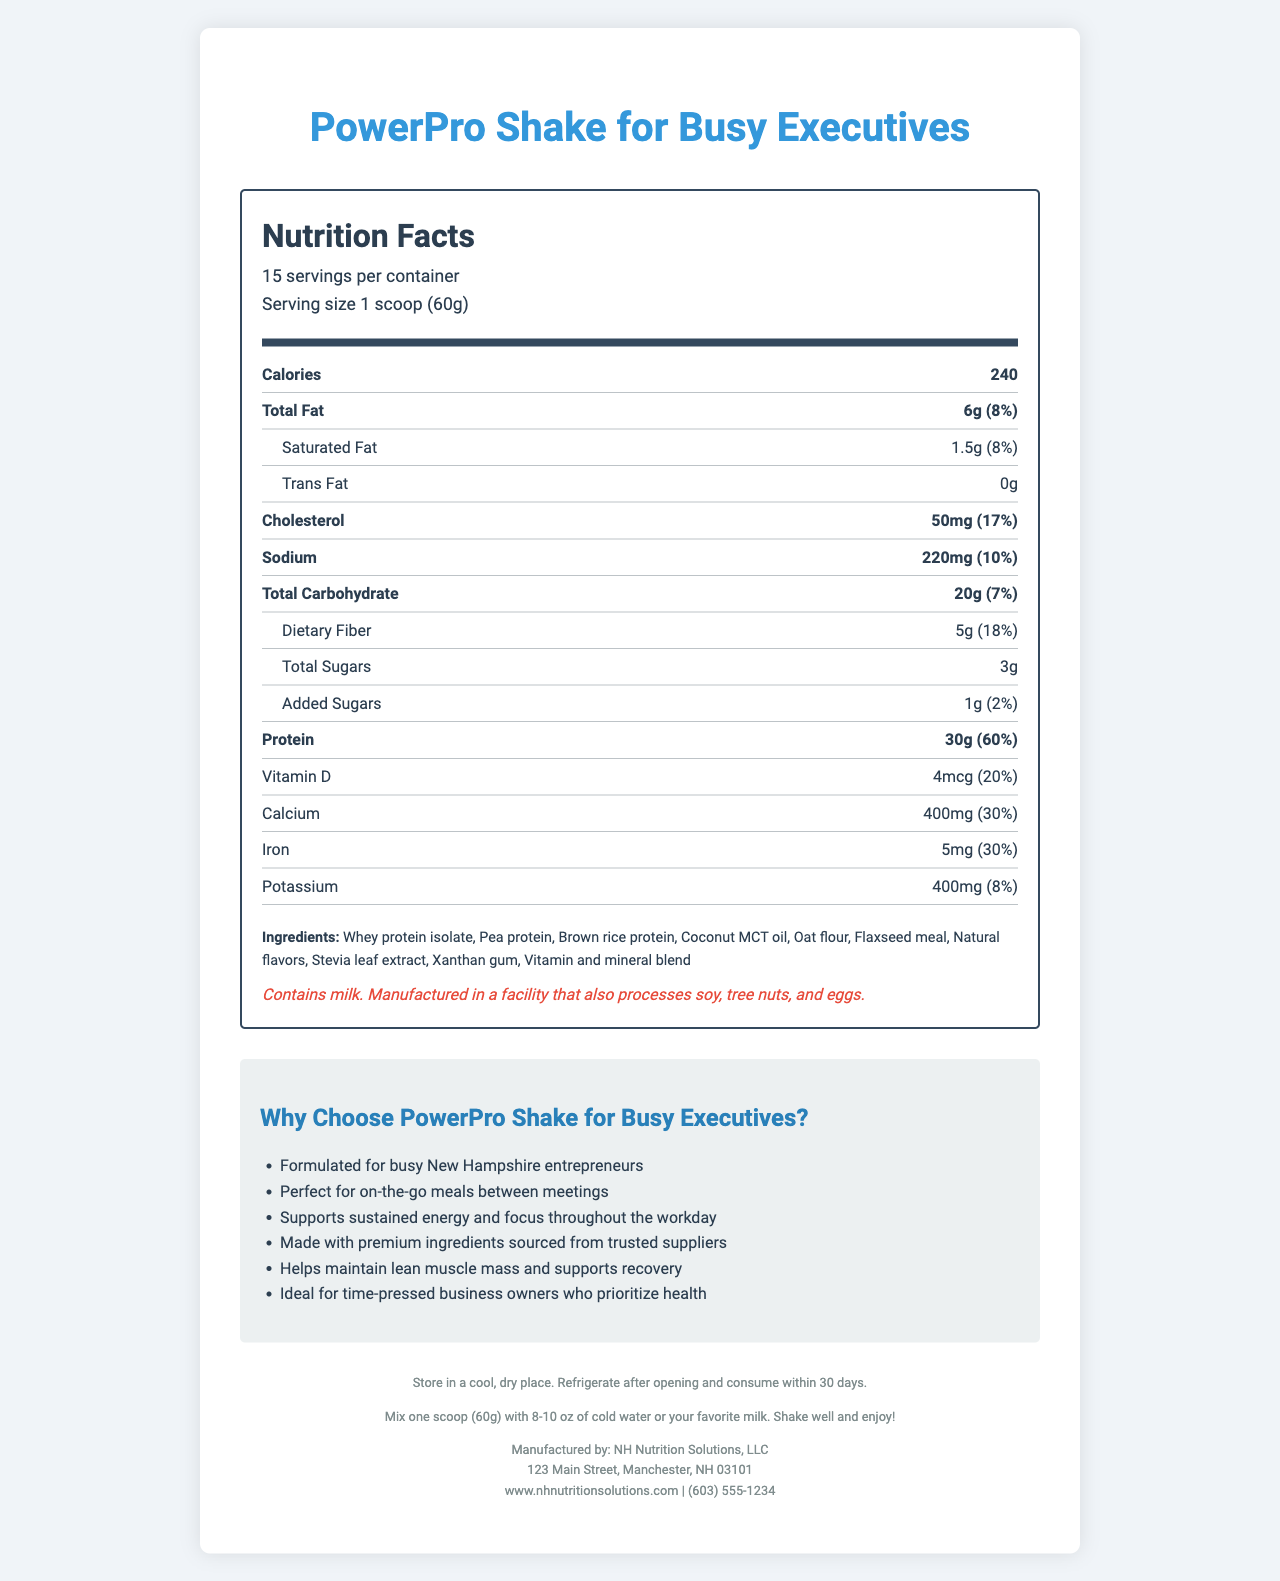what is the product name? The product name is clearly stated at the top and in the title of the document.
Answer: PowerPro Shake for Busy Executives how many servings are there per container? According to the serving information, there are 15 servings per container.
Answer: 15 how much protein does one serving contain? The nutritional facts section indicates that one serving contains 30g of protein.
Answer: 30g what is the daily value percentage of dietary fiber in one serving? The document lists the daily value percentage of dietary fiber in one serving as 18%.
Answer: 18% how many calories are in one serving? The calorie count per serving is prominently displayed in the nutrition facts section.
Answer: 240 what is the amount of cholesterol in one serving? The nutritional information shows that one serving contains 50mg of cholesterol.
Answer: 50mg which ingredient is listed first in the ingredients section? Ingredients are usually listed in order of quantity, and whey protein isolate is listed first.
Answer: Whey protein isolate what is the daily value percentage of calcium? The daily value percentage of calcium is noted as 30%.
Answer: 30% which of these vitamins have a daily value percentage of 50%? A. Vitamin D B. Vitamin B12 C. Vitamin C Vitamin C has a daily percentage value of 50%, which matches the correct option C.
Answer: C what is the daily value percentage of Vitamin B12? A. 20% B. 30% C. 50% D. 100% The daily value of Vitamin B12 is 100%, matching option D.
Answer: D does the product contain any allergens? The allergen information states that the product contains milk and is manufactured in a facility that processes soy, tree nuts, and eggs.
Answer: Yes is the product made for a specific demographic? The marketing claims specify that the product is formulated for busy New Hampshire entrepreneurs, indicating a specific target audience.
Answer: Yes is there information about the flavor of the shake? The document lists "natural flavors" among the ingredients but does not specify any particular flavor.
Answer: No describe the main idea of the document. The document focuses on presenting a comprehensive nutritional profile and highlights key benefits tailored for its target audience, helping them make informed choices.
Answer: The document provides detailed nutritional information about the "PowerPro Shake for Busy Executives," a high-protein meal replacement shake designed for busy business owners. It emphasizes the product's nutritional benefits, the premium ingredients used, and its suitability for busy entrepreneurs. Additional information includes serving size, daily values of various nutrients, ingredient list, allergen information, storage instructions, and contact details for the manufacturer. how many grams of total sugars are in one serving? The total sugars in one serving are listed as 3g.
Answer: 3g is the product suitable for vegans? The document does not provide enough information to determine if the product is suitable for vegans. It contains whey protein isolate which is derived from milk, but the other ingredients are plant-based which creates ambiguity without further manufacturing details.
Answer: Cannot be determined what is the contact phone number for the manufacturer? The document lists the contact phone number at the bottom as (603) 555-1234.
Answer: (603) 555-1234 where is the manufacturer located? The address at the bottom of the document provides the manufacturer's location.
Answer: 123 Main Street, Manchester, NH 03101 